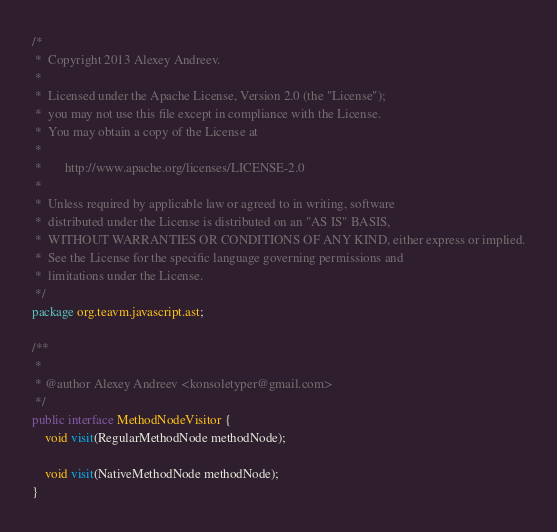<code> <loc_0><loc_0><loc_500><loc_500><_Java_>/*
 *  Copyright 2013 Alexey Andreev.
 *
 *  Licensed under the Apache License, Version 2.0 (the "License");
 *  you may not use this file except in compliance with the License.
 *  You may obtain a copy of the License at
 *
 *       http://www.apache.org/licenses/LICENSE-2.0
 *
 *  Unless required by applicable law or agreed to in writing, software
 *  distributed under the License is distributed on an "AS IS" BASIS,
 *  WITHOUT WARRANTIES OR CONDITIONS OF ANY KIND, either express or implied.
 *  See the License for the specific language governing permissions and
 *  limitations under the License.
 */
package org.teavm.javascript.ast;

/**
 *
 * @author Alexey Andreev <konsoletyper@gmail.com>
 */
public interface MethodNodeVisitor {
    void visit(RegularMethodNode methodNode);

    void visit(NativeMethodNode methodNode);
}
</code> 